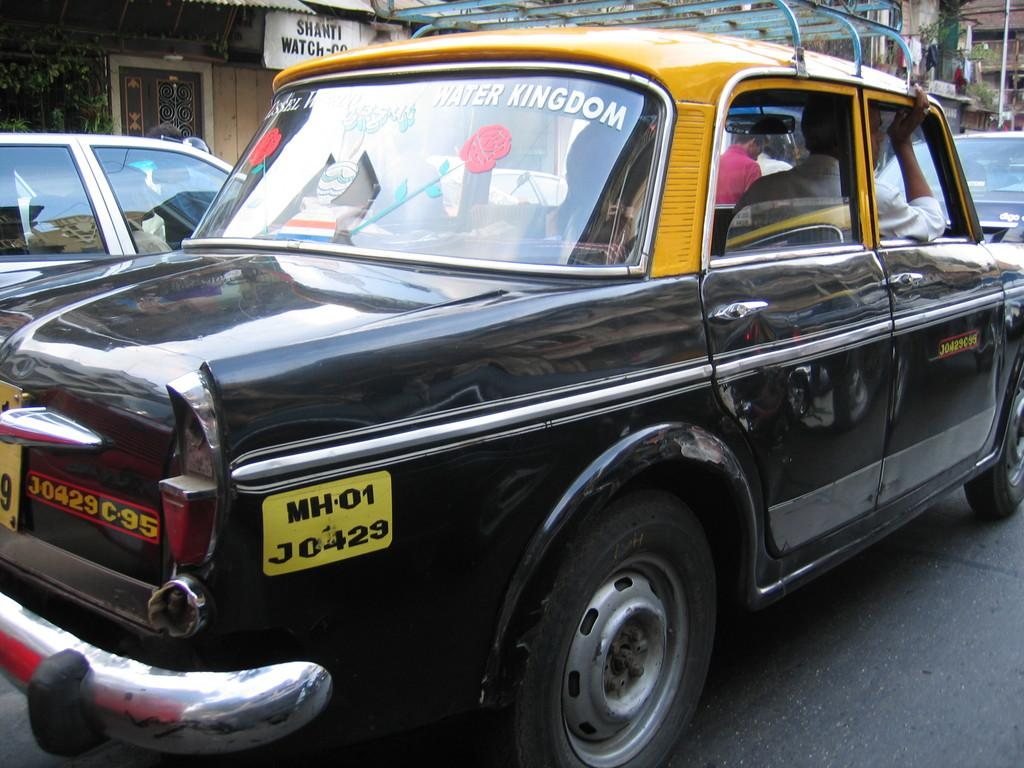What can be seen on the road in the image? There are cars on the road in the image. What are the people in the cars doing? People are sitting in the cars. What type of structures can be seen in the background of the image? There are sheds in the background of the image. What color is the kitty sitting on the roof of the car in the image? There is no kitty present in the image, and therefore no such color can be determined. 